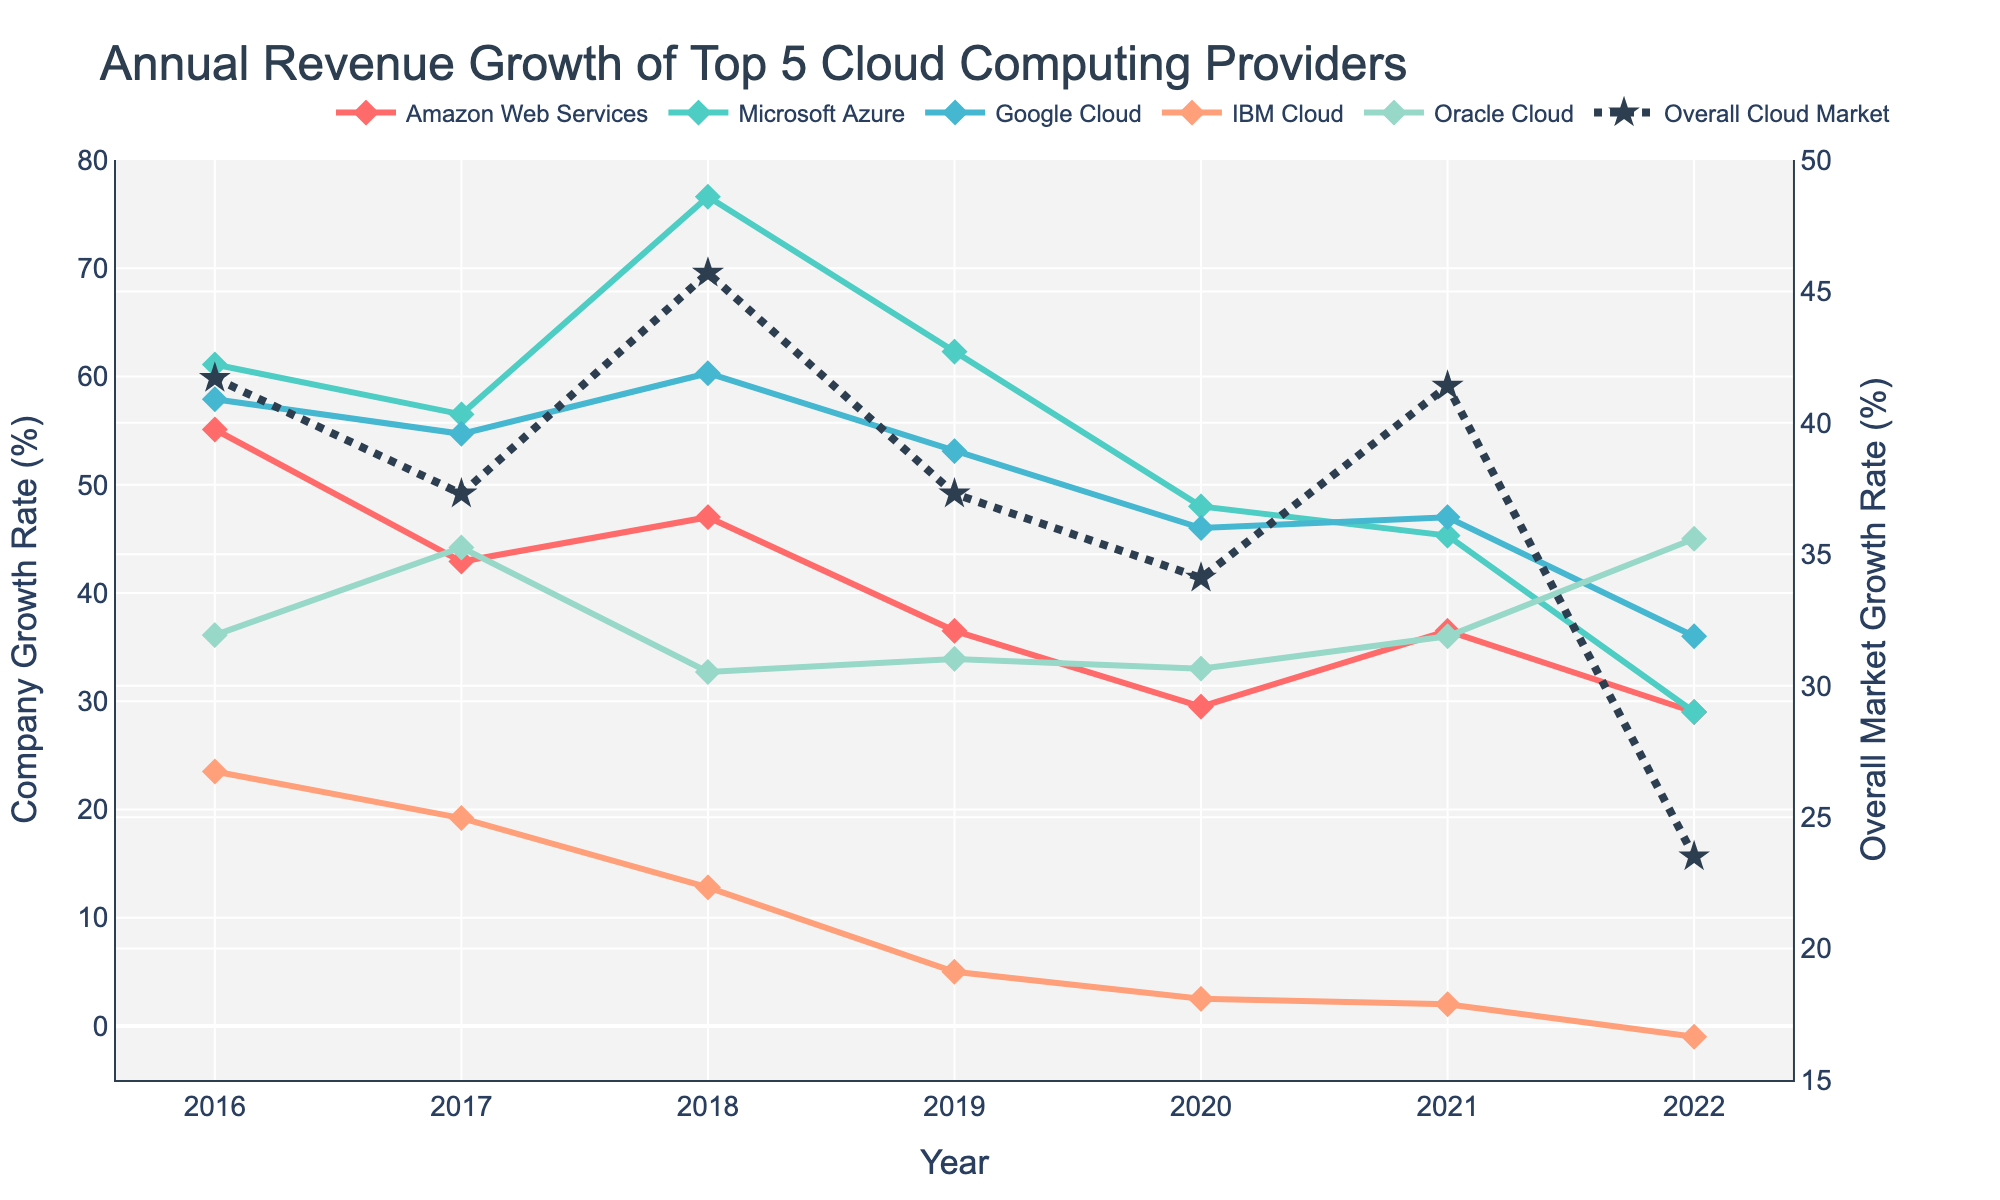What's the trend for Amazon Web Services' annual revenue growth from 2016 to 2022? To identify the trend, examine the line for Amazon Web Services (AWS) from the leftmost point (2016) to the rightmost point (2022). The initial value is 55.1% growth in 2016, dropping in some years but showing an overall downward trend with a slight fluctuation. In 2022, AWS had a 29.0% growth rate.
Answer: A downward trend with some fluctuations Which company had the highest revenue growth rate in 2018? Look for the peak points across all company lines in the year 2018. Microsoft Azure's line reaches the highest at 76.6%.
Answer: Microsoft Azure How did IBM Cloud's growth compare from 2019 to 2020? To compare IBM Cloud's growth between 2019 and 2020, look at the line for IBM Cloud in these years: 
IBM Cloud had a 5.0% growth in 2019 and a 2.5% growth in 2020.
Calculating the difference: 5.0% - 2.5% = 2.5%.
Answer: IBM Cloud's growth decreased by 2.5% Which provider had the most stable revenue growth trend over the years? Observing the lines for each company from 2016 to 2022, the one with the least fluctuation and most horizontal slope indicates stability. Oracle Cloud's line appears the most stable with gentle inclines and declines, staying between 32.7% and 45.0%.
Answer: Oracle Cloud What was the overall cloud market growth rate in 2021 compared to 2022? Compare the values of the "Overall Cloud Market" line in 2021 and 2022. In 2021, the growth rate was 41.4%, and in 2022, it was 23.5%. 
Subtract 23.5% from 41.4% to get the difference: 41.4% - 23.5% = 17.9%.
Answer: It decreased by 17.9% What is the overall market growth trend from 2016 to 2022? Examine the plot line titled "Overall Cloud Market." Starting at 41.7% in 2016, then showing an increase, a peak at 45.7% in 2018, followed by a general downward trend to 23.5% in 2022.
Answer: Generally downward with an initial rise Which provider had negative growth, and in which year? Identify any dips below zero on the plot lines. IBM Cloud shows a value of -1.0% in 2022.
Answer: IBM Cloud in 2022 Compare Google Cloud's revenue growth rate in 2019 and 2020. What's the difference? Check the values of Google Cloud for 2019 and 2020:
- 2019: 53.1%
- 2020: 46.0%
Subtract 46.0% from 53.1%, resulting in a difference of 53.1% - 46.0% = 7.1%.
Answer: 7.1% decrease Which company's growth rate most closely follows the overall market trend? Visually compare the shape and direction of each company's line with the "Overall Cloud Market" line. Amazon Web Services (AWS) has a more similar shape, particularly from 2016 to 2020.
Answer: Amazon Web Services (AWS) 